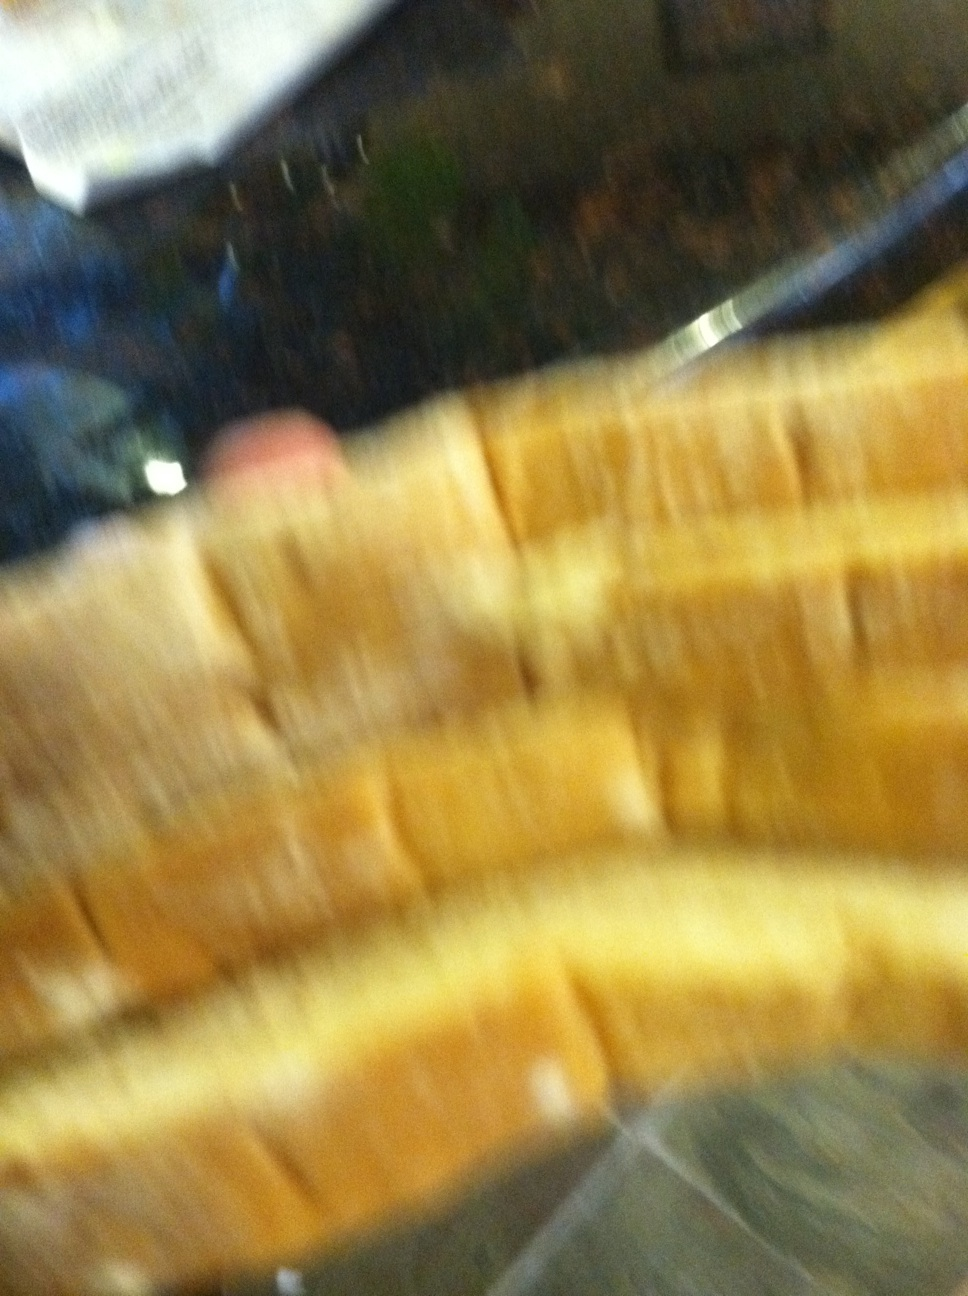And now it goes dead. The image appears to be blurry. It looks like a few slices of bread, perhaps some sort of loaf like sandwich bread. It's hard to tell exactly what's going on from this picture alone. 